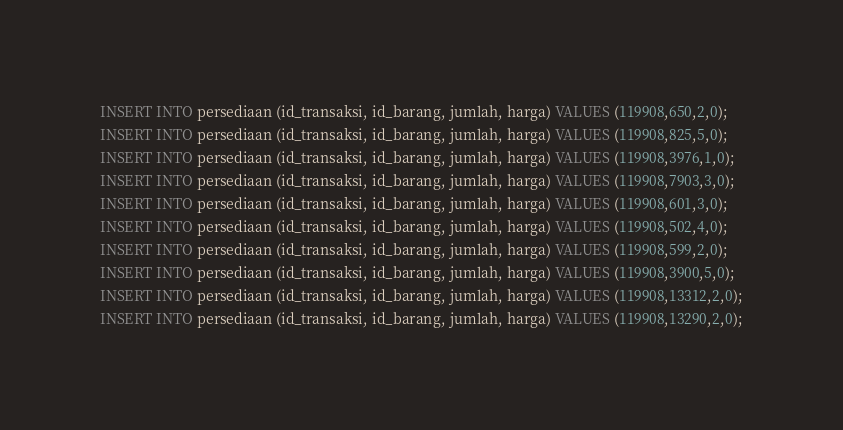Convert code to text. <code><loc_0><loc_0><loc_500><loc_500><_SQL_>INSERT INTO persediaan (id_transaksi, id_barang, jumlah, harga) VALUES (119908,650,2,0);
INSERT INTO persediaan (id_transaksi, id_barang, jumlah, harga) VALUES (119908,825,5,0);
INSERT INTO persediaan (id_transaksi, id_barang, jumlah, harga) VALUES (119908,3976,1,0);
INSERT INTO persediaan (id_transaksi, id_barang, jumlah, harga) VALUES (119908,7903,3,0);
INSERT INTO persediaan (id_transaksi, id_barang, jumlah, harga) VALUES (119908,601,3,0);
INSERT INTO persediaan (id_transaksi, id_barang, jumlah, harga) VALUES (119908,502,4,0);
INSERT INTO persediaan (id_transaksi, id_barang, jumlah, harga) VALUES (119908,599,2,0);
INSERT INTO persediaan (id_transaksi, id_barang, jumlah, harga) VALUES (119908,3900,5,0);
INSERT INTO persediaan (id_transaksi, id_barang, jumlah, harga) VALUES (119908,13312,2,0);
INSERT INTO persediaan (id_transaksi, id_barang, jumlah, harga) VALUES (119908,13290,2,0);
</code> 